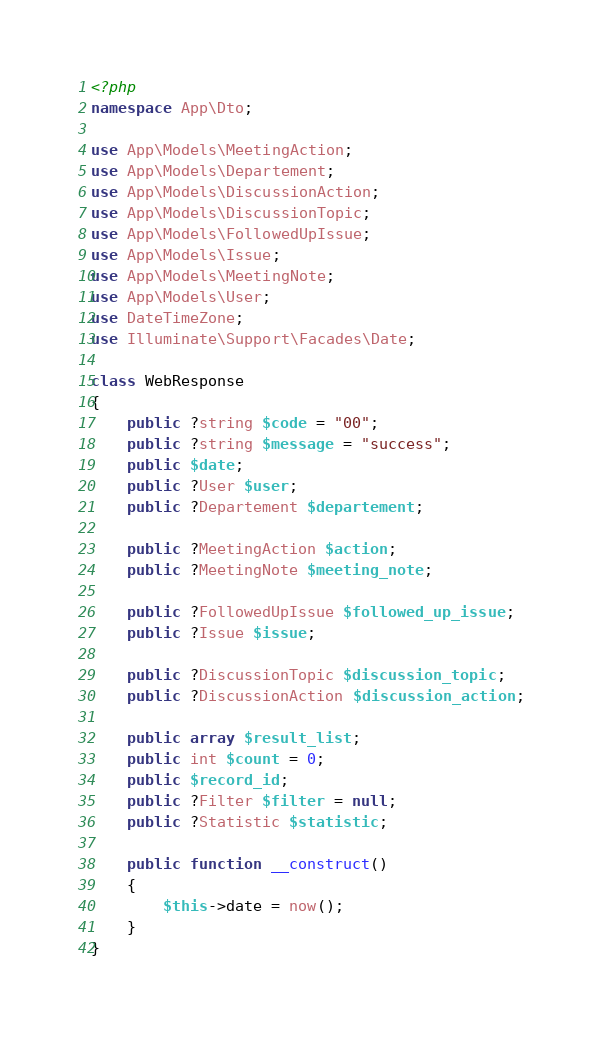Convert code to text. <code><loc_0><loc_0><loc_500><loc_500><_PHP_><?php
namespace App\Dto;

use App\Models\MeetingAction;
use App\Models\Departement;
use App\Models\DiscussionAction;
use App\Models\DiscussionTopic;
use App\Models\FollowedUpIssue;
use App\Models\Issue;
use App\Models\MeetingNote;
use App\Models\User;
use DateTimeZone;
use Illuminate\Support\Facades\Date;

class WebResponse
{
    public ?string $code = "00";
    public ?string $message = "success";
    public $date;
    public ?User $user;
    public ?Departement $departement;
    
    public ?MeetingAction $action;
    public ?MeetingNote $meeting_note;

    public ?FollowedUpIssue $followed_up_issue;
    public ?Issue $issue;

    public ?DiscussionTopic $discussion_topic;
    public ?DiscussionAction $discussion_action;
    
    public array $result_list;
    public int $count = 0;
    public $record_id;
    public ?Filter $filter = null;
    public ?Statistic $statistic;

    public function __construct()
    {
        $this->date = now();
    }
}</code> 